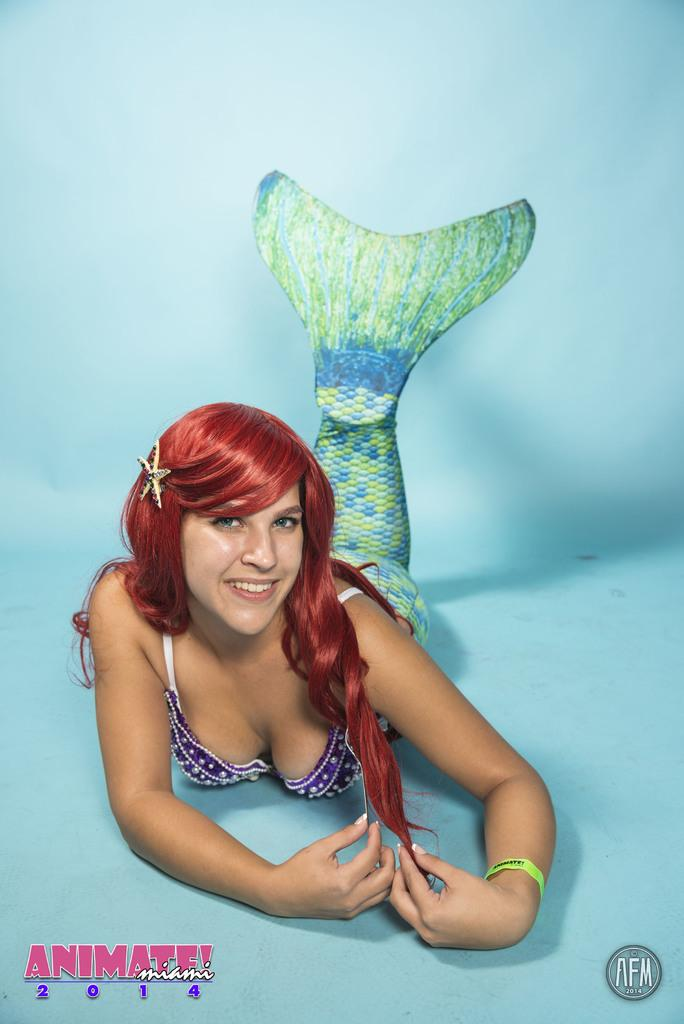Who is the main subject in the image? There is a lady in the image. What is the lady doing in the image? The lady is lying on the floor. What color is the floor in the image? The floor is painted with blue color. What type of destruction can be seen in the image? There is no destruction present in the image; it features a lady lying on a blue-colored floor. 